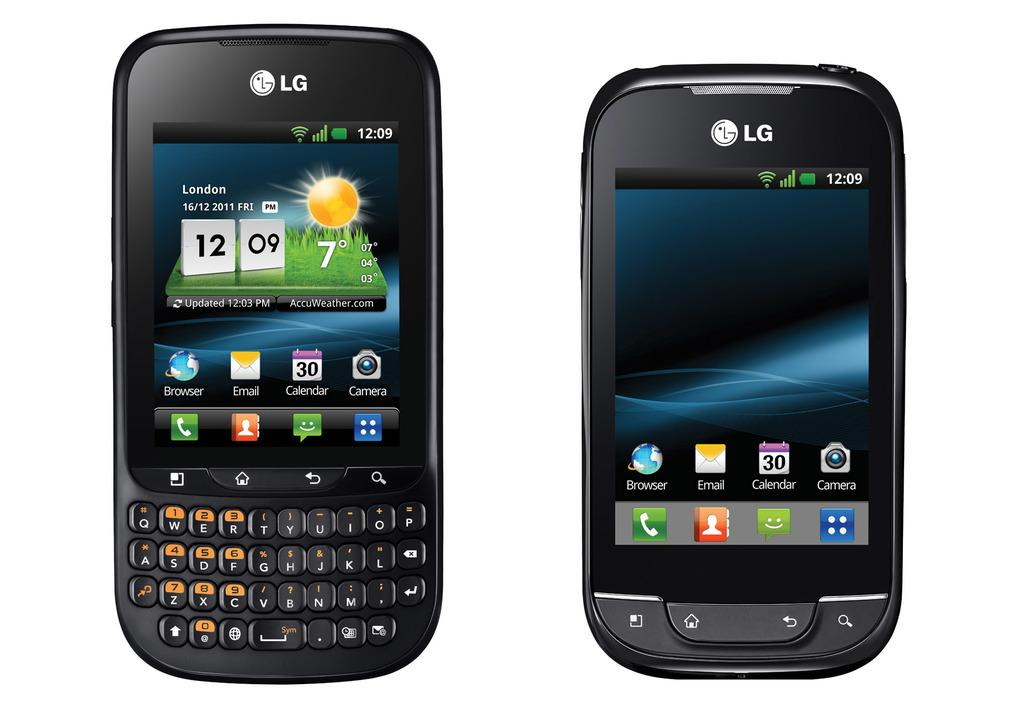<image>
Describe the image concisely. Two different cellphones from LG where one is showing London 16/12/2011 with the sun on the screen and the other shows the screen blank. 